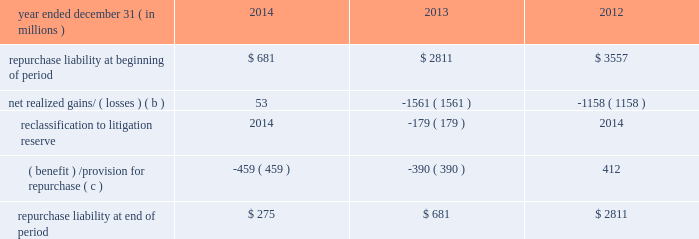Jpmorgan chase & co./2014 annual report 291 therefore , are not recorded on the consolidated balance sheets until settlement date .
The unsettled reverse repurchase agreements and securities borrowing agreements predominantly consist of agreements with regular-way settlement periods .
Loan sales- and securitization-related indemnifications mortgage repurchase liability in connection with the firm 2019s mortgage loan sale and securitization activities with the gses , as described in note 16 , the firm has made representations and warranties that the loans sold meet certain requirements .
The firm has been , and may be , required to repurchase loans and/or indemnify the gses ( e.g. , with 201cmake-whole 201d payments to reimburse the gses for their realized losses on liquidated loans ) .
To the extent that repurchase demands that are received relate to loans that the firm purchased from third parties that remain viable , the firm typically will have the right to seek a recovery of related repurchase losses from the third party .
Generally , the maximum amount of future payments the firm would be required to make for breaches of these representations and warranties would be equal to the unpaid principal balance of such loans that are deemed to have defects that were sold to purchasers ( including securitization-related spes ) plus , in certain circumstances , accrued interest on such loans and certain expense .
The table summarizes the change in the mortgage repurchase liability for each of the periods presented .
Summary of changes in mortgage repurchase liability ( a ) year ended december 31 , ( in millions ) 2014 2013 2012 repurchase liability at beginning of period $ 681 $ 2811 $ 3557 net realized gains/ ( losses ) ( b ) 53 ( 1561 ) ( 1158 ) .
( benefit ) /provision for repurchase ( c ) ( 459 ) ( 390 ) 412 repurchase liability at end of period $ 275 $ 681 $ 2811 ( a ) on october 25 , 2013 , the firm announced that it had reached a $ 1.1 billion agreement with the fhfa to resolve , other than certain limited types of exposures , outstanding and future mortgage repurchase demands associated with loans sold to the gses from 2000 to 2008 .
( b ) presented net of third-party recoveries and included principal losses and accrued interest on repurchased loans , 201cmake-whole 201d settlements , settlements with claimants , and certain related expense .
Make-whole settlements were $ 11 million , $ 414 million and $ 524 million , for the years ended december 31 , 2014 , 2013 and 2012 , respectively .
( c ) included a provision related to new loan sales of $ 4 million , $ 20 million and $ 112 million , for the years ended december 31 , 2014 , 2013 and 2012 , respectively .
Private label securitizations the liability related to repurchase demands associated with private label securitizations is separately evaluated by the firm in establishing its litigation reserves .
On november 15 , 2013 , the firm announced that it had reached a $ 4.5 billion agreement with 21 major institutional investors to make a binding offer to the trustees of 330 residential mortgage-backed securities trusts issued by j.p.morgan , chase , and bear stearns ( 201crmbs trust settlement 201d ) to resolve all representation and warranty claims , as well as all servicing claims , on all trusts issued by j.p .
Morgan , chase , and bear stearns between 2005 and 2008 .
The seven trustees ( or separate and successor trustees ) for this group of 330 trusts have accepted the rmbs trust settlement for 319 trusts in whole or in part and excluded from the settlement 16 trusts in whole or in part .
The trustees 2019 acceptance is subject to a judicial approval proceeding initiated by the trustees , which is pending in new york state court .
In addition , from 2005 to 2008 , washington mutual made certain loan level representations and warranties in connection with approximately $ 165 billion of residential mortgage loans that were originally sold or deposited into private-label securitizations by washington mutual .
Of the $ 165 billion , approximately $ 78 billion has been repaid .
In addition , approximately $ 49 billion of the principal amount of such loans has liquidated with an average loss severity of 59% ( 59 % ) .
Accordingly , the remaining outstanding principal balance of these loans as of december 31 , 2014 , was approximately $ 38 billion , of which $ 8 billion was 60 days or more past due .
The firm believes that any repurchase obligations related to these loans remain with the fdic receivership .
For additional information regarding litigation , see note 31 .
Loans sold with recourse the firm provides servicing for mortgages and certain commercial lending products on both a recourse and nonrecourse basis .
In nonrecourse servicing , the principal credit risk to the firm is the cost of temporary servicing advances of funds ( i.e. , normal servicing advances ) .
In recourse servicing , the servicer agrees to share credit risk with the owner of the mortgage loans , such as fannie mae or freddie mac or a private investor , insurer or guarantor .
Losses on recourse servicing predominantly occur when foreclosure sales proceeds of the property underlying a defaulted loan are less than the sum of the outstanding principal balance , plus accrued interest on the loan and the cost of holding and disposing of the underlying property .
The firm 2019s securitizations are predominantly nonrecourse , thereby effectively transferring the risk of future credit losses to the purchaser of the mortgage-backed securities issued by the trust .
At december 31 , 2014 and 2013 , the unpaid principal balance of loans sold with recourse totaled $ 6.1 billion and $ 7.7 billion , respectively .
The carrying value of the related liability that the firm has recorded , which is representative of the firm 2019s view of the likelihood it .
What was the ratio of the total unpaid principal balance of loans sold with recourse for 2014 to 2013? 
Computations: (6.1 / 7.7)
Answer: 0.79221. 